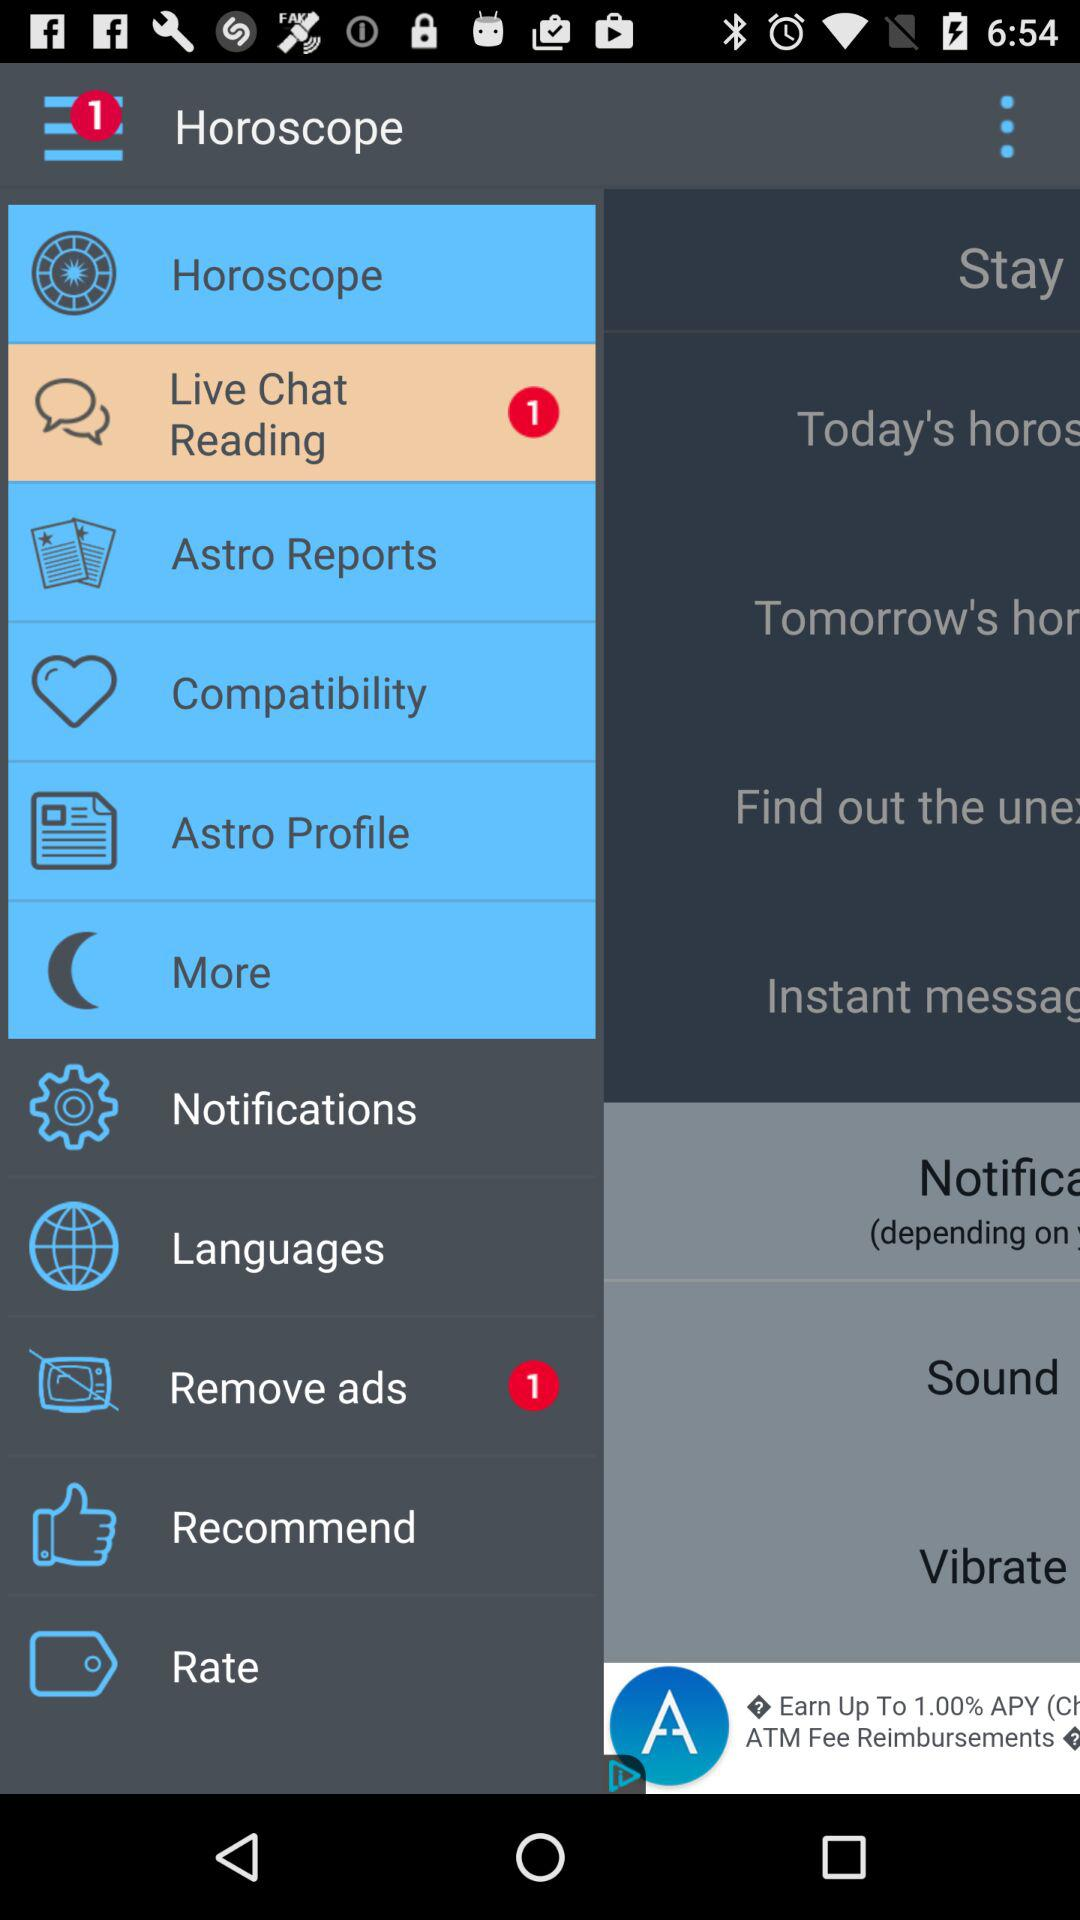What is the application name? The application name is "Horoscope". 